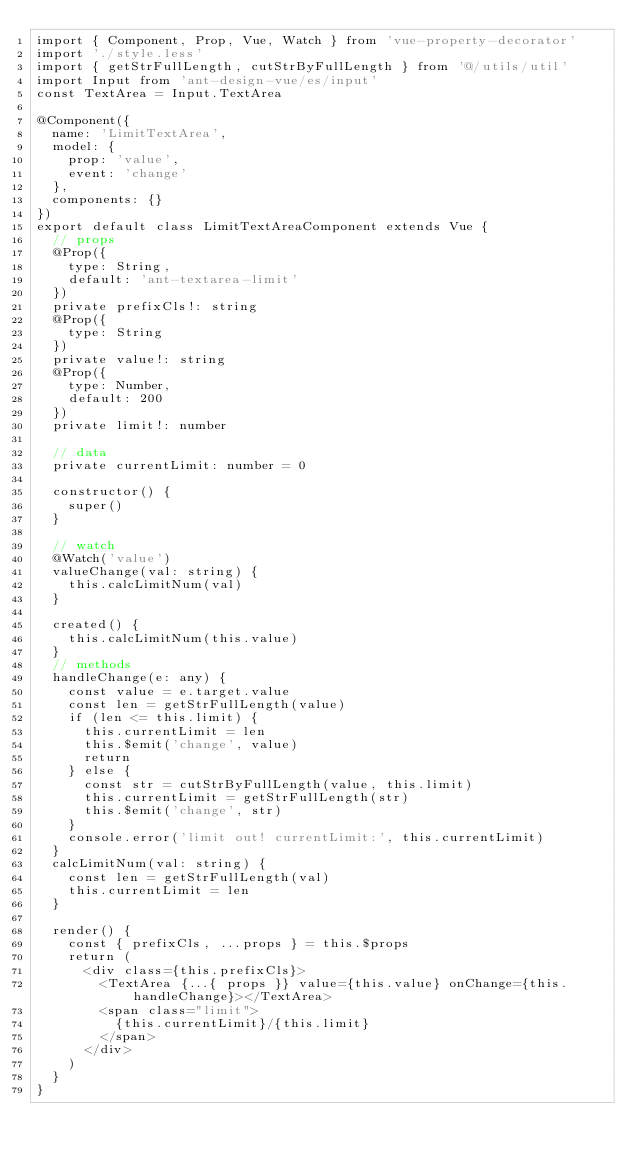Convert code to text. <code><loc_0><loc_0><loc_500><loc_500><_TypeScript_>import { Component, Prop, Vue, Watch } from 'vue-property-decorator'
import './style.less'
import { getStrFullLength, cutStrByFullLength } from '@/utils/util'
import Input from 'ant-design-vue/es/input'
const TextArea = Input.TextArea

@Component({
  name: 'LimitTextArea',
  model: {
    prop: 'value',
    event: 'change'
  },
  components: {}
})
export default class LimitTextAreaComponent extends Vue {
  // props
  @Prop({
    type: String,
    default: 'ant-textarea-limit'
  })
  private prefixCls!: string
  @Prop({
    type: String
  })
  private value!: string
  @Prop({
    type: Number,
    default: 200
  })
  private limit!: number

  // data
  private currentLimit: number = 0

  constructor() {
    super()
  }

  // watch
  @Watch('value')
  valueChange(val: string) {
    this.calcLimitNum(val)
  }

  created() {
    this.calcLimitNum(this.value)
  }
  // methods
  handleChange(e: any) {
    const value = e.target.value
    const len = getStrFullLength(value)
    if (len <= this.limit) {
      this.currentLimit = len
      this.$emit('change', value)
      return
    } else {
      const str = cutStrByFullLength(value, this.limit)
      this.currentLimit = getStrFullLength(str)
      this.$emit('change', str)
    }
    console.error('limit out! currentLimit:', this.currentLimit)
  }
  calcLimitNum(val: string) {
    const len = getStrFullLength(val)
    this.currentLimit = len
  }

  render() {
    const { prefixCls, ...props } = this.$props
    return (
      <div class={this.prefixCls}>
        <TextArea {...{ props }} value={this.value} onChange={this.handleChange}></TextArea>
        <span class="limit">
          {this.currentLimit}/{this.limit}
        </span>
      </div>
    )
  }
}
</code> 